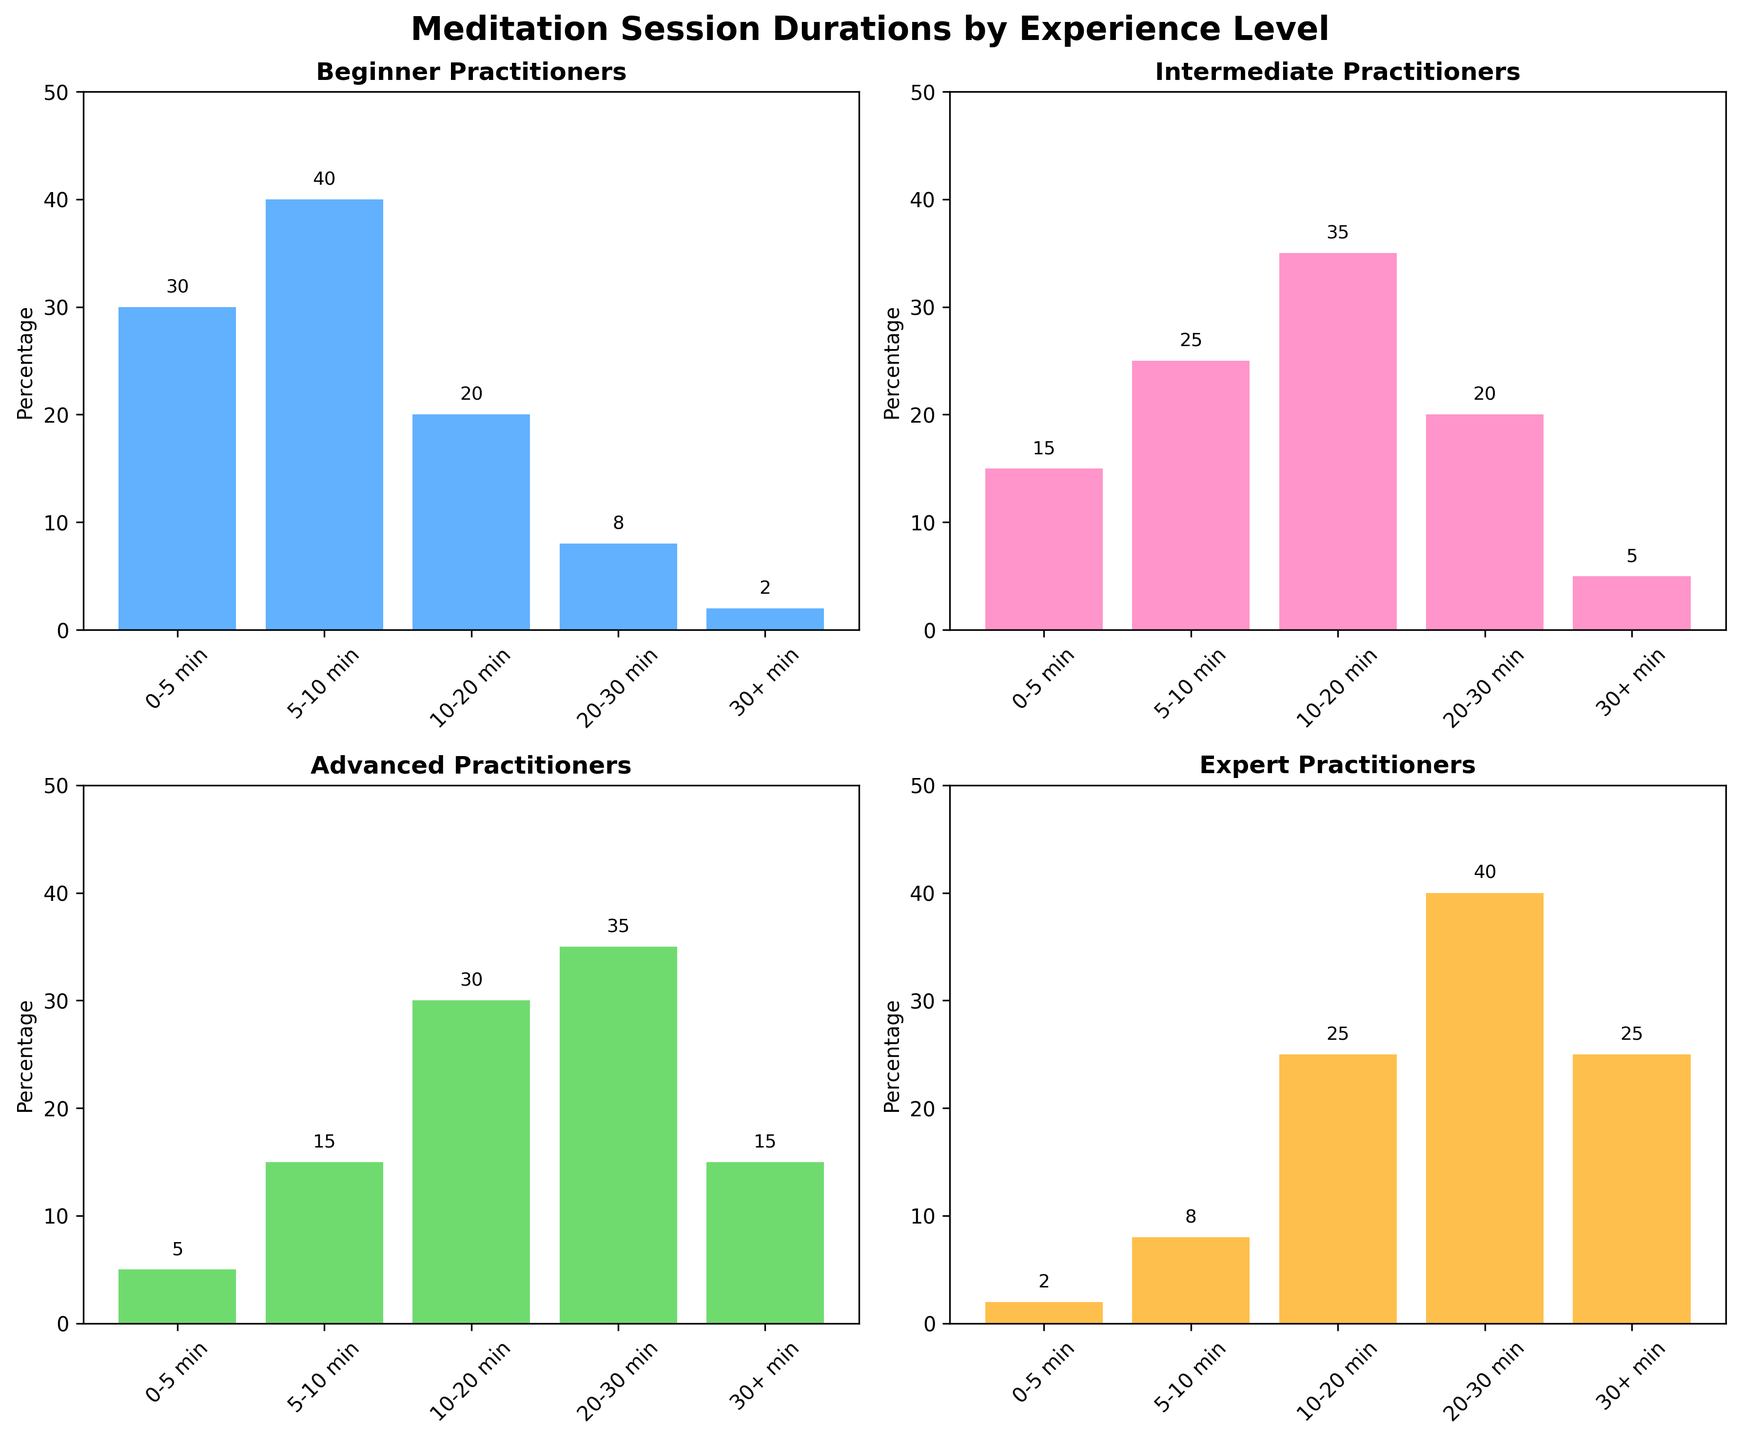What is the title of the figure? The title of the figure is usually found at the top of the visual, summarizing what the figure represents. In this case, the title is written above the subplots.
Answer: Meditation Session Durations by Experience Level Which experience level has the highest percentage for '10-20 min' meditation sessions? By looking at the '10-20 min' category across the different subplots, we can determine which bar is the tallest. In this case, it is in the Expert Practitioners subplot.
Answer: Expert How many categories of meditation session durations are represented? The duration categories can be found by looking at the x-axis labels in any of the subplots. Here, the figure has five categories listed for session durations.
Answer: 5 What is the total percentage for 'Beginner' practitioners who meditate for more than 20 minutes? We sum the percentages of the '20-30 min' and '30+ min' categories in the 'Beginner' subplot: 8 + 2.
Answer: 10 Which experience level shows a decrease in the percentage of practitioners as the duration increases? To find this, we need to look at the height of the bars for each duration in every subplot. The 'Beginner' level shows a decreasing trend from left to right.
Answer: Beginner Compare the percentage of 'Intermediate' and 'Advanced' practitioners for '20-30 min' meditation sessions. Which group has more? By visually comparing the height of the '20-30 min' bar in both the 'Intermediate' and 'Advanced' subplots, it is clear that the bar is taller for 'Advanced' practitioners.
Answer: Advanced What is the sum of percentages for 'Intermediate' practitioners meditating from 0-10 minutes? We add the percentages from the '0-5 min' and '5-10 min' categories in the 'Intermediate' subplot: 15 + 25.
Answer: 40 Which categories for 'Expert' practitioners have the same percentage? By observing the heights of the bars in the 'Expert' subplot, we see that the '25%' appears twice in the '10-20 min' and '30+ min' categories.
Answer: 10-20 min and 30+ min Which experience level has the steepest increase in the percentage of practitioners when moving from '10-20 min' to '20-30 min'? The steepest increase can be found by comparing the differences between these two bars in each subplot. The 'Expert' practitioners show the largest increase (from 25% to 40%).
Answer: Expert 